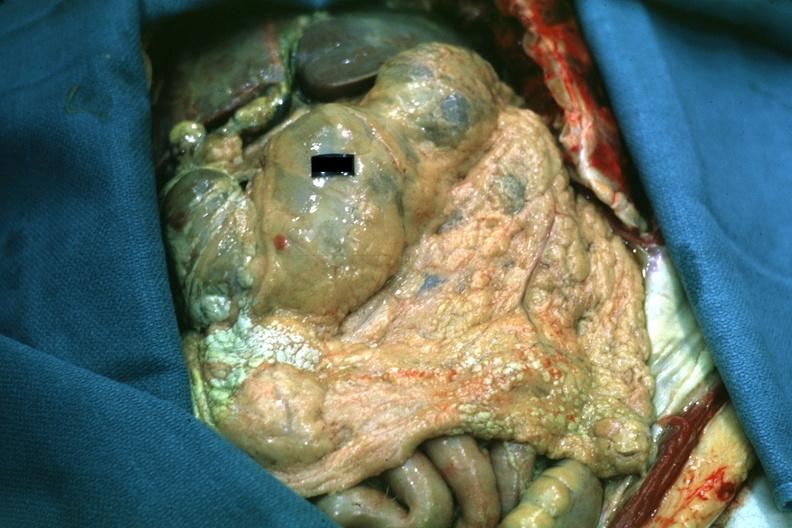what is present?
Answer the question using a single word or phrase. Fat necrosis 